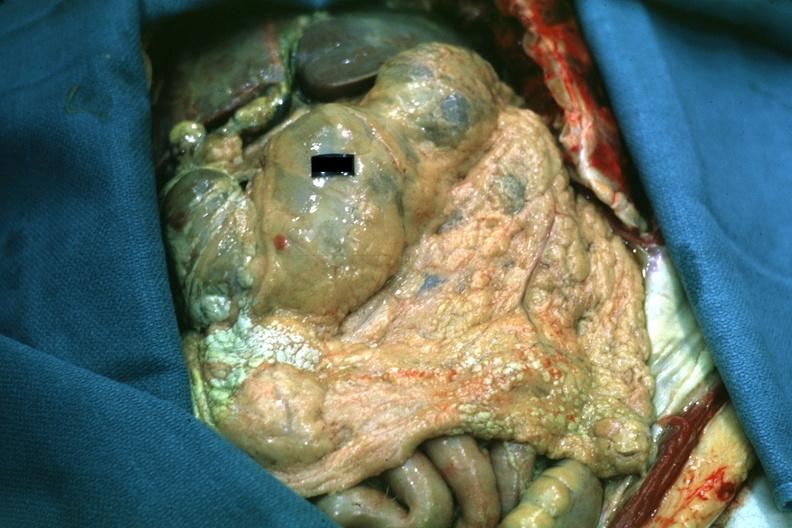what is present?
Answer the question using a single word or phrase. Fat necrosis 